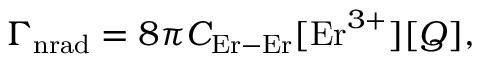Convert formula to latex. <formula><loc_0><loc_0><loc_500><loc_500>{ \Gamma } _ { n r a d } = 8 \pi C _ { E r - E r } [ E r ^ { 3 + } ] [ Q ] ,</formula> 